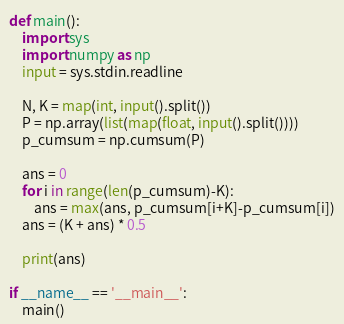Convert code to text. <code><loc_0><loc_0><loc_500><loc_500><_Python_>def main():
    import sys
    import numpy as np
    input = sys.stdin.readline

    N, K = map(int, input().split())
    P = np.array(list(map(float, input().split())))
    p_cumsum = np.cumsum(P)

    ans = 0
    for i in range(len(p_cumsum)-K):
        ans = max(ans, p_cumsum[i+K]-p_cumsum[i])
    ans = (K + ans) * 0.5

    print(ans)

if __name__ == '__main__':
    main()</code> 